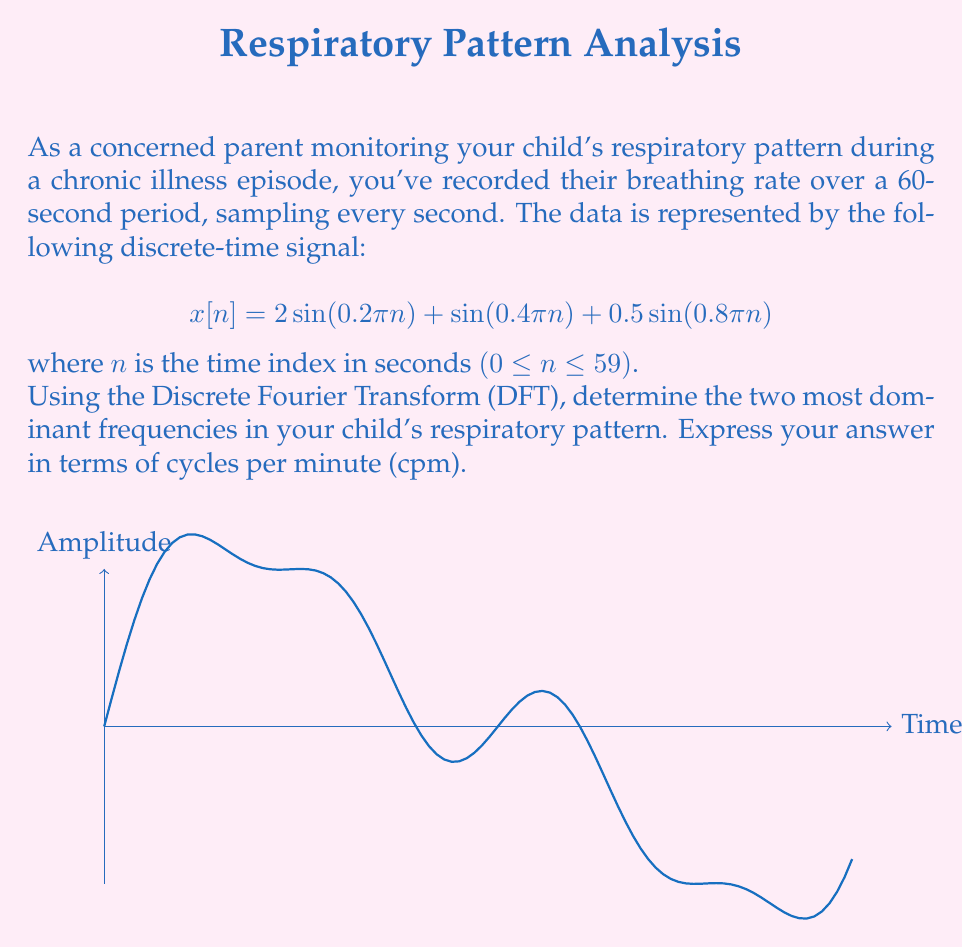Can you solve this math problem? To solve this problem, we'll follow these steps:

1) First, recall that the DFT of a signal $x[n]$ is given by:

   $$X[k] = \sum_{n=0}^{N-1} x[n]e^{-j2\pi kn/N}$$

   where $N$ is the total number of samples (60 in this case).

2) The frequencies in the signal are:
   $f_1 = 0.2\pi/2\pi = 0.1$ cycles/sample
   $f_2 = 0.4\pi/2\pi = 0.2$ cycles/sample
   $f_3 = 0.8\pi/2\pi = 0.4$ cycles/sample

3) To convert these to DFT bin numbers, multiply by N:
   $k_1 = 0.1 * 60 = 6$
   $k_2 = 0.2 * 60 = 12$
   $k_3 = 0.4 * 60 = 24$

4) The magnitude of the DFT at these bins will be proportional to the amplitudes in the original signal:
   $|X[6]| \propto 2$
   $|X[12]| \propto 1$
   $|X[24]| \propto 0.5$

5) The two largest magnitudes correspond to $k_1 = 6$ and $k_2 = 12$.

6) To convert from DFT bin numbers to frequencies in cycles per minute:
   $f_{cpm} = \frac{k}{N} * f_s * 60$
   where $f_s$ is the sampling frequency (1 Hz in this case)

   For $k_1 = 6$: $f_{cpm} = \frac{6}{60} * 1 * 60 = 6$ cpm
   For $k_2 = 12$: $f_{cpm} = \frac{12}{60} * 1 * 60 = 12$ cpm

Therefore, the two most dominant frequencies are 6 cpm and 12 cpm.
Answer: 6 cpm and 12 cpm 